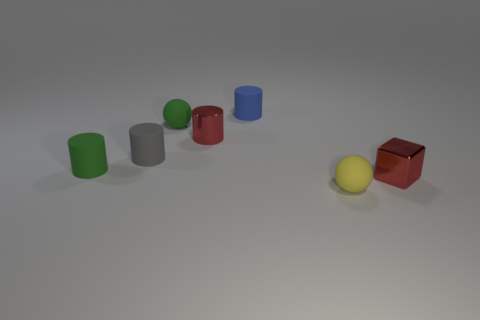Add 1 red cylinders. How many objects exist? 8 Subtract all balls. How many objects are left? 5 Add 1 small blue rubber cylinders. How many small blue rubber cylinders are left? 2 Add 7 tiny yellow rubber objects. How many tiny yellow rubber objects exist? 8 Subtract 1 gray cylinders. How many objects are left? 6 Subtract all large yellow cylinders. Subtract all small cylinders. How many objects are left? 3 